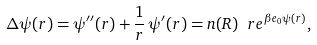<formula> <loc_0><loc_0><loc_500><loc_500>\Delta \psi ( r ) = \psi ^ { \prime \prime } ( r ) + \frac { 1 } { r } \, \psi ^ { \prime } ( r ) = n ( R ) \ r e ^ { \beta e _ { 0 } \psi ( r ) } ,</formula> 